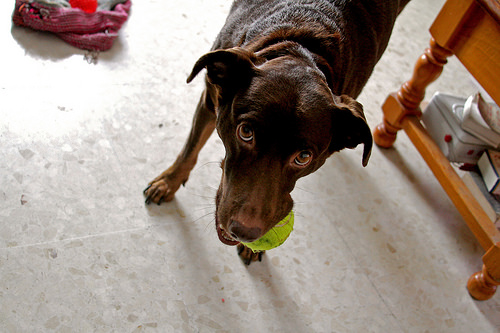<image>
Is there a dog above the ball? No. The dog is not positioned above the ball. The vertical arrangement shows a different relationship. 